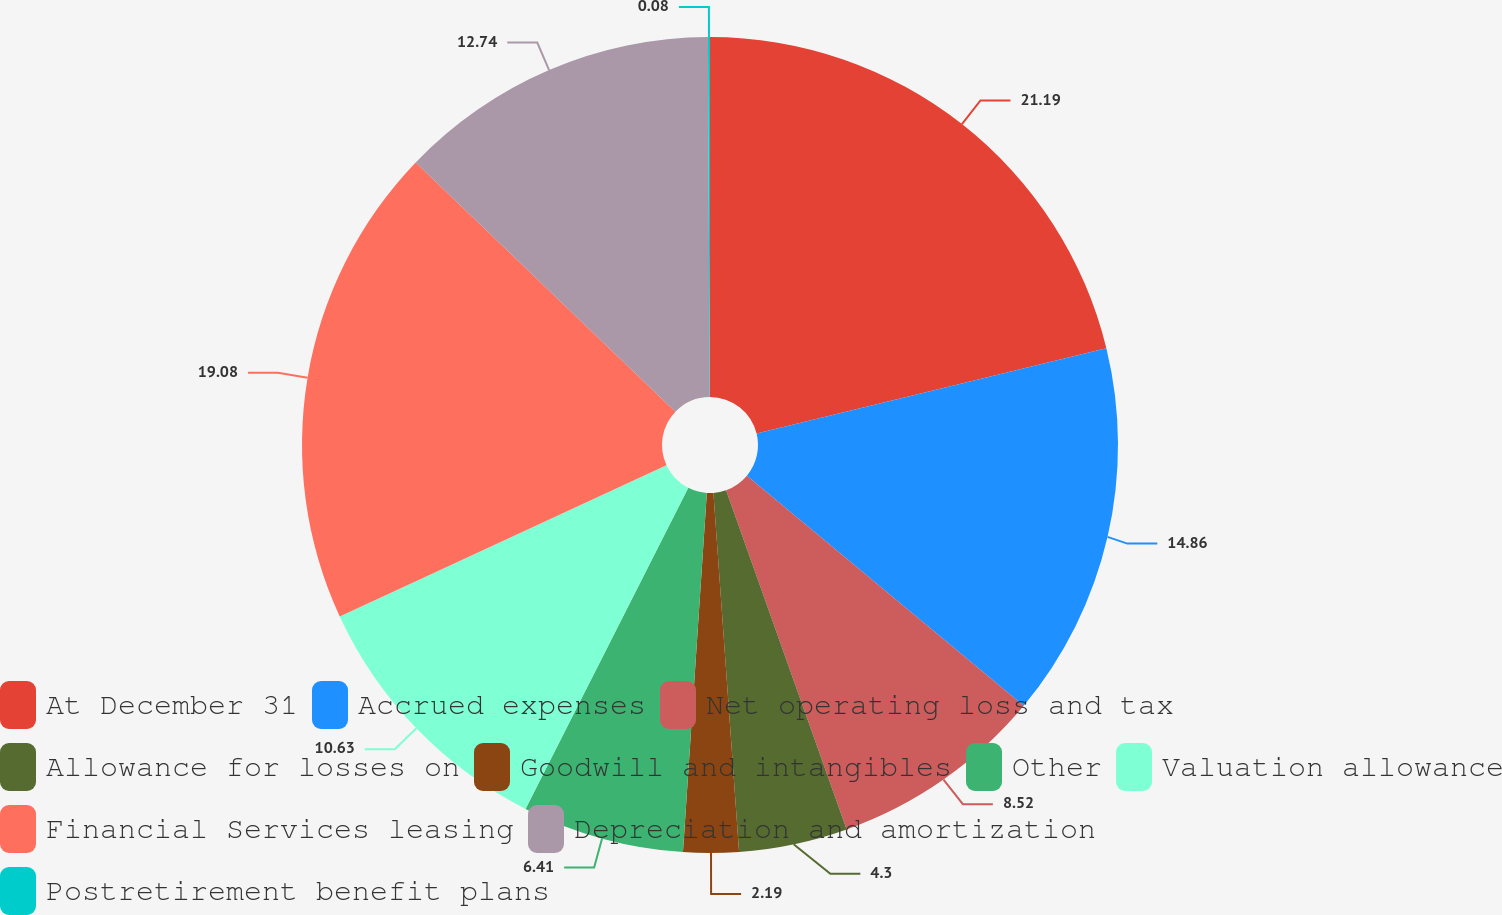Convert chart. <chart><loc_0><loc_0><loc_500><loc_500><pie_chart><fcel>At December 31<fcel>Accrued expenses<fcel>Net operating loss and tax<fcel>Allowance for losses on<fcel>Goodwill and intangibles<fcel>Other<fcel>Valuation allowance<fcel>Financial Services leasing<fcel>Depreciation and amortization<fcel>Postretirement benefit plans<nl><fcel>21.18%<fcel>14.85%<fcel>8.52%<fcel>4.3%<fcel>2.19%<fcel>6.41%<fcel>10.63%<fcel>19.07%<fcel>12.74%<fcel>0.08%<nl></chart> 